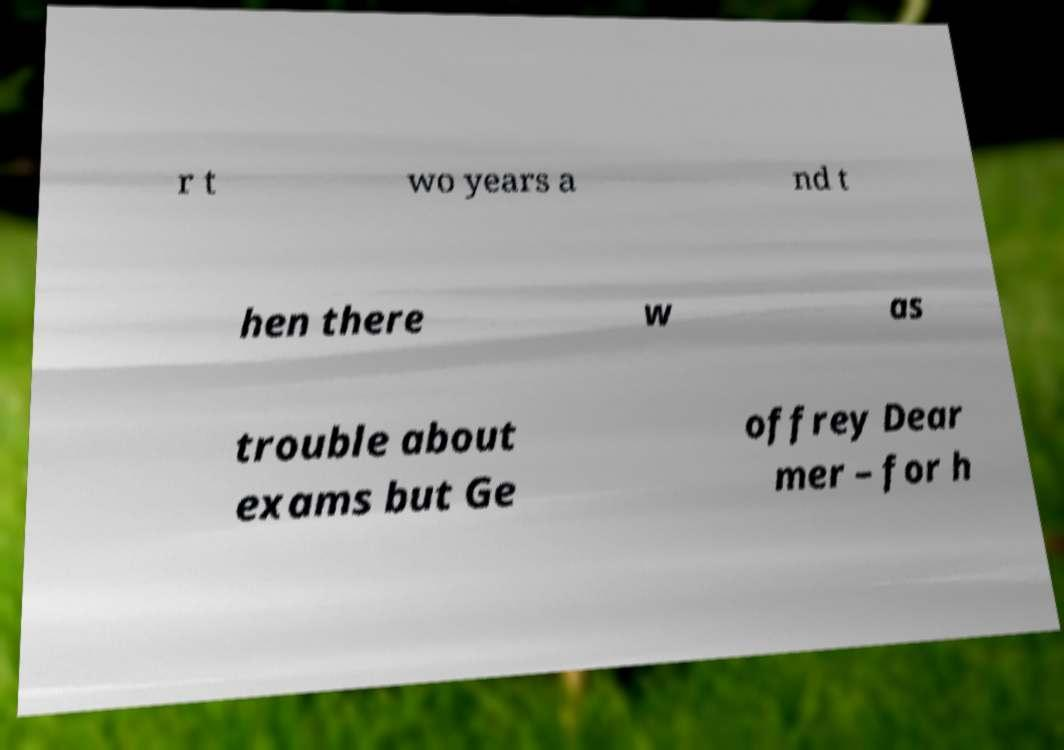There's text embedded in this image that I need extracted. Can you transcribe it verbatim? r t wo years a nd t hen there w as trouble about exams but Ge offrey Dear mer – for h 